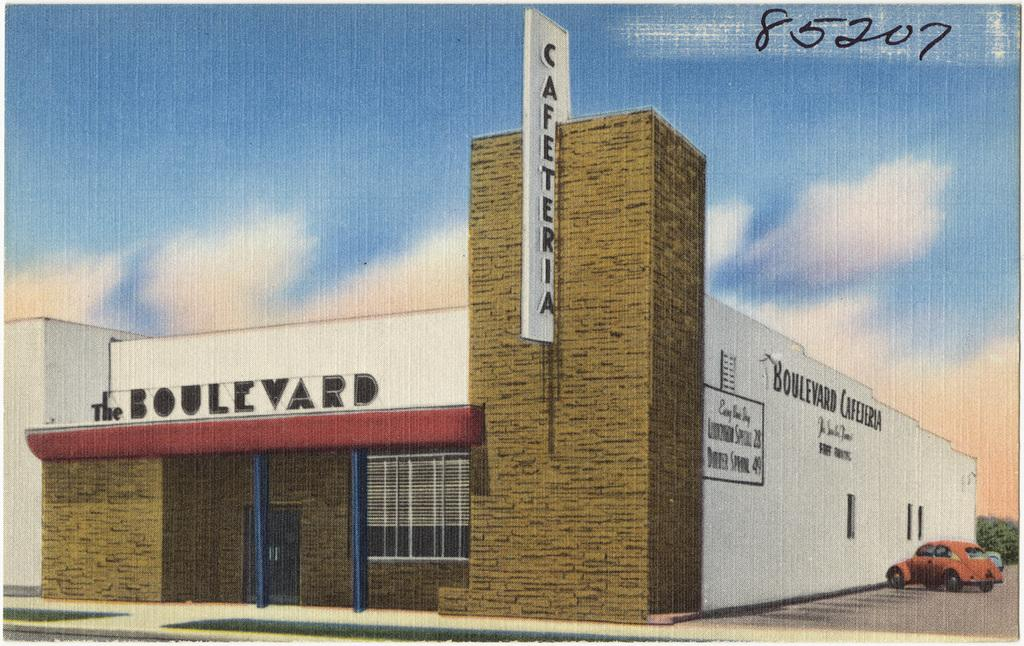What is the weather like in the image? The sky is cloudy in the image. What type of structure is visible in the image? There is a building with windows in the image. Are there any advertisements or signs on the building? Yes, there are hoardings on the building. What is located beside the building? There is a tree beside the building. What else can be seen in the image? Vehicles are present in the image. Is there any text or number visible in the image? Yes, there is a five-digit number in the top right corner of the image. How many sheep are grazing in the image? There are no sheep present in the image. Is there a net covering the building in the image? There is no net covering the building in the image. 